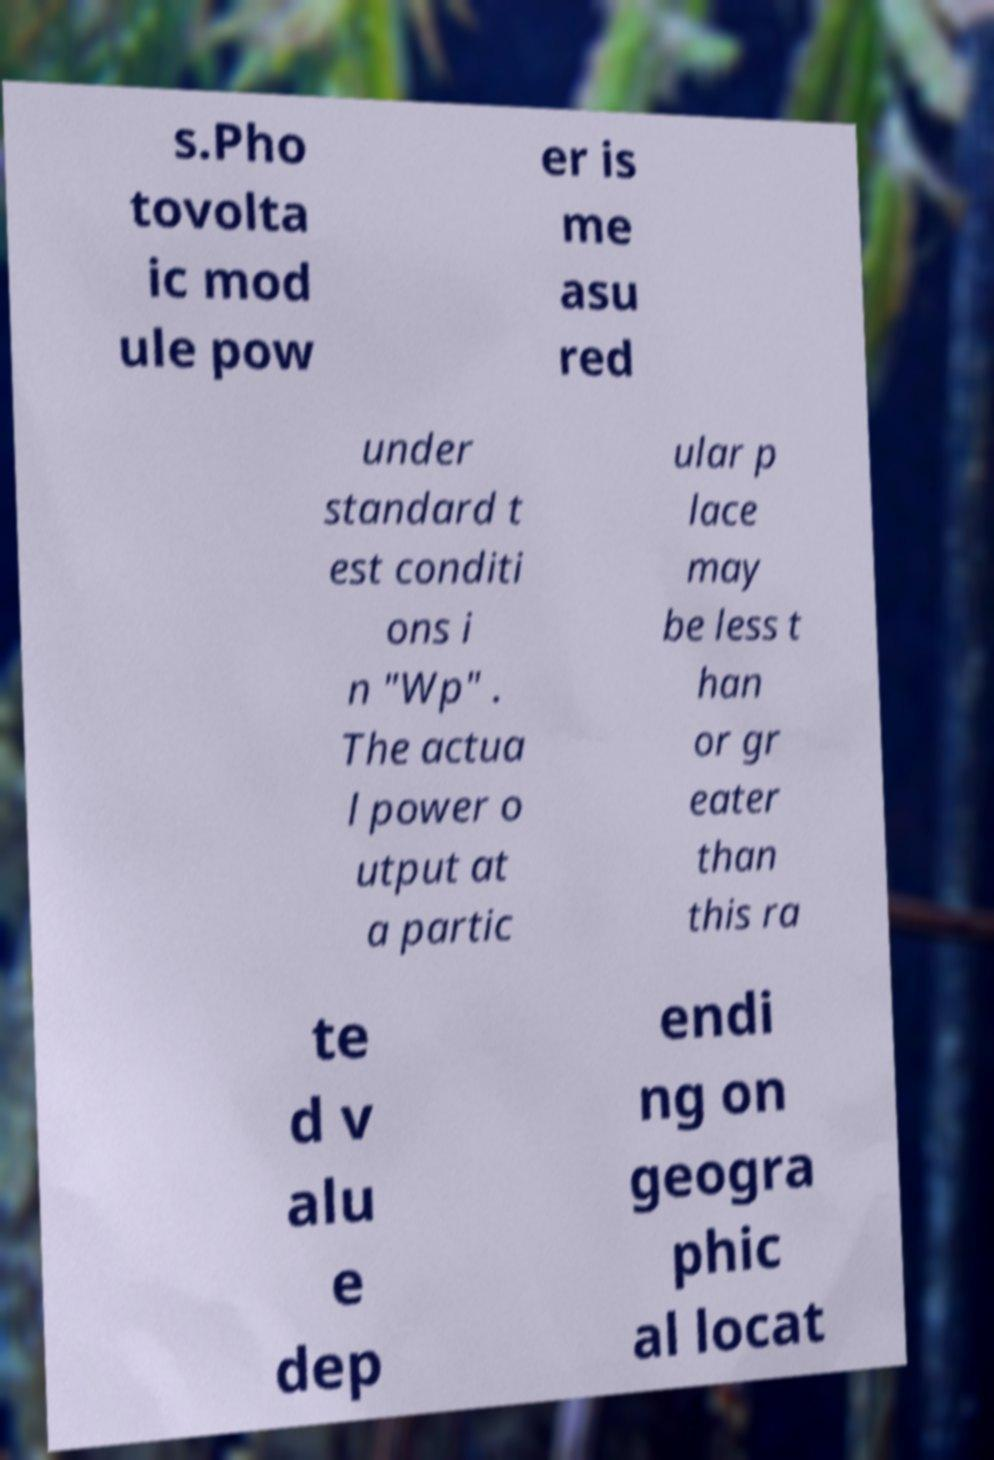There's text embedded in this image that I need extracted. Can you transcribe it verbatim? s.Pho tovolta ic mod ule pow er is me asu red under standard t est conditi ons i n "Wp" . The actua l power o utput at a partic ular p lace may be less t han or gr eater than this ra te d v alu e dep endi ng on geogra phic al locat 